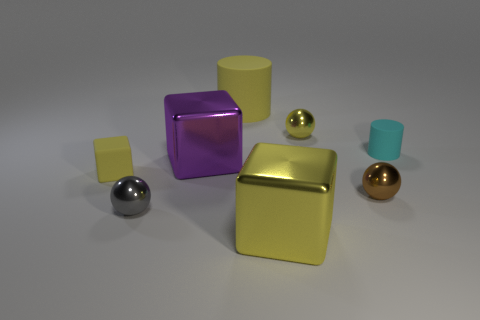What number of tiny metal spheres are in front of the small matte thing that is right of the gray metal sphere? 2 